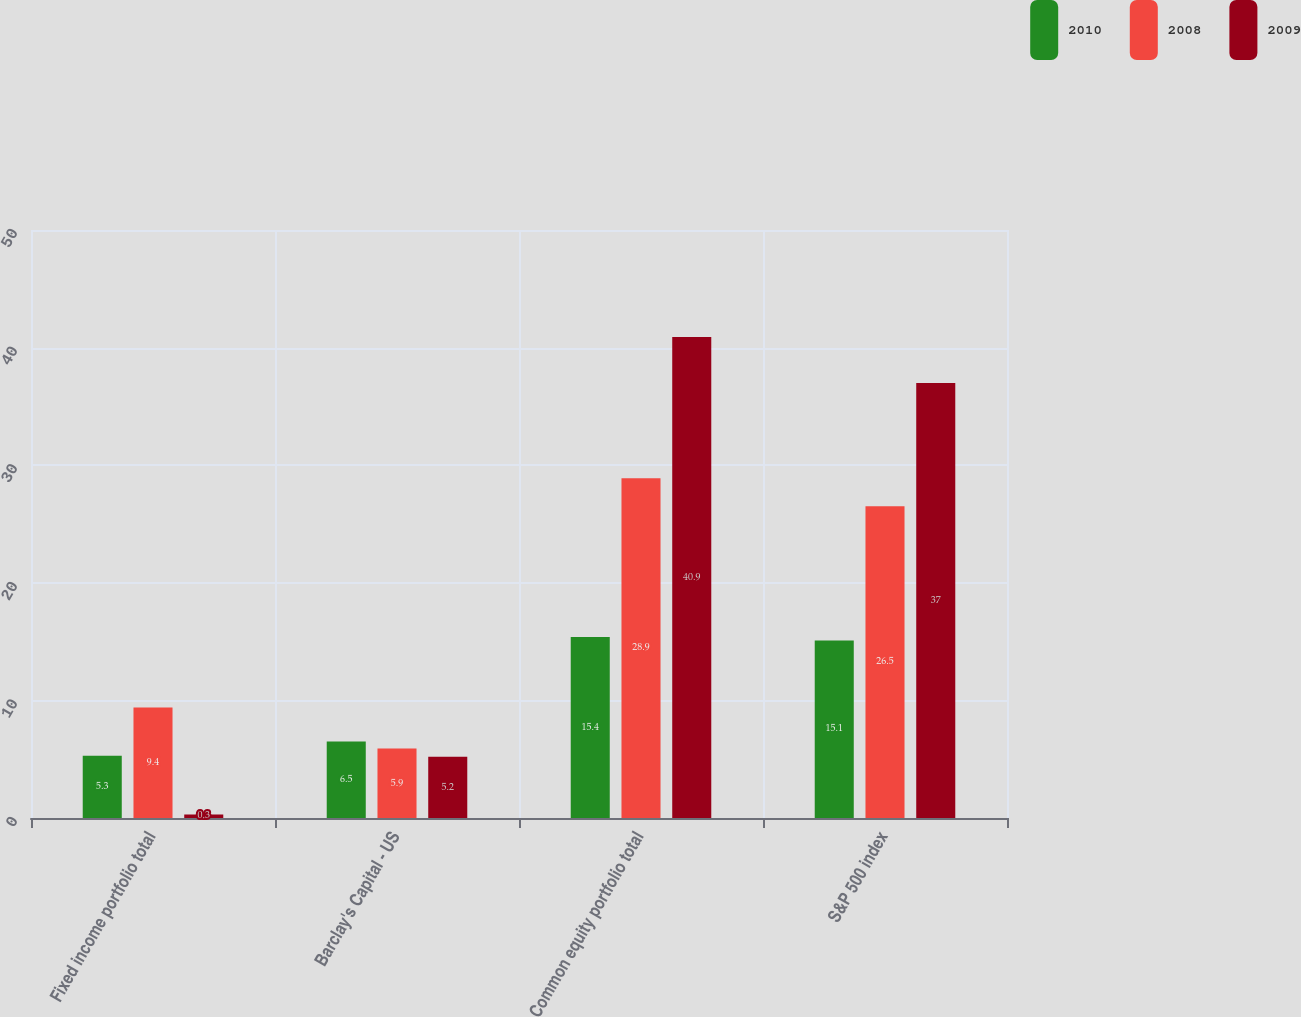Convert chart to OTSL. <chart><loc_0><loc_0><loc_500><loc_500><stacked_bar_chart><ecel><fcel>Fixed income portfolio total<fcel>Barclay's Capital - US<fcel>Common equity portfolio total<fcel>S&P 500 index<nl><fcel>2010<fcel>5.3<fcel>6.5<fcel>15.4<fcel>15.1<nl><fcel>2008<fcel>9.4<fcel>5.9<fcel>28.9<fcel>26.5<nl><fcel>2009<fcel>0.3<fcel>5.2<fcel>40.9<fcel>37<nl></chart> 